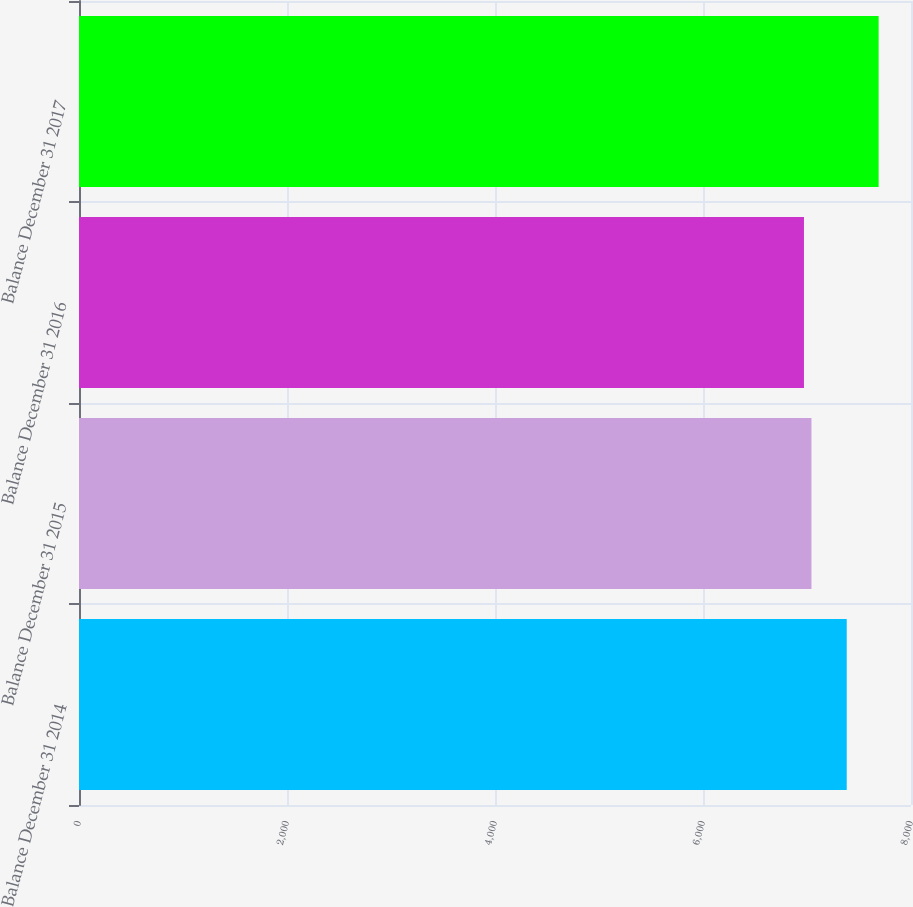Convert chart to OTSL. <chart><loc_0><loc_0><loc_500><loc_500><bar_chart><fcel>Balance December 31 2014<fcel>Balance December 31 2015<fcel>Balance December 31 2016<fcel>Balance December 31 2017<nl><fcel>7382.1<fcel>7042.68<fcel>6970.9<fcel>7688.7<nl></chart> 